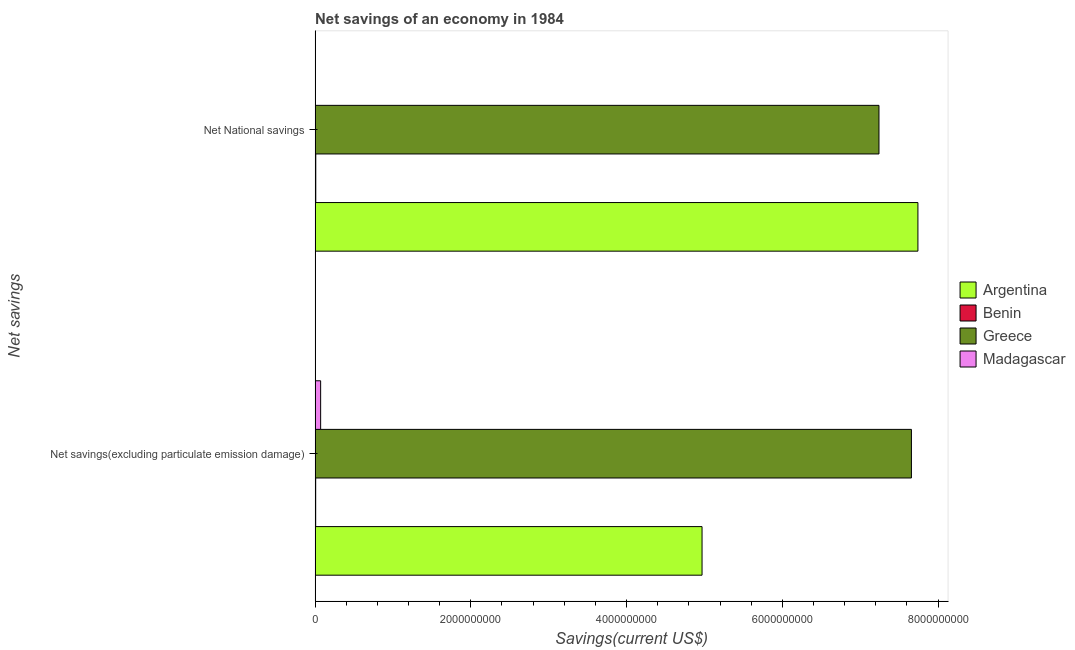How many groups of bars are there?
Make the answer very short. 2. Are the number of bars on each tick of the Y-axis equal?
Keep it short and to the point. No. What is the label of the 2nd group of bars from the top?
Your answer should be compact. Net savings(excluding particulate emission damage). What is the net national savings in Benin?
Keep it short and to the point. 8.73e+06. Across all countries, what is the maximum net savings(excluding particulate emission damage)?
Keep it short and to the point. 7.66e+09. In which country was the net national savings maximum?
Offer a very short reply. Argentina. What is the total net savings(excluding particulate emission damage) in the graph?
Give a very brief answer. 1.27e+1. What is the difference between the net savings(excluding particulate emission damage) in Madagascar and that in Greece?
Your answer should be very brief. -7.59e+09. What is the difference between the net national savings in Madagascar and the net savings(excluding particulate emission damage) in Argentina?
Your response must be concise. -4.97e+09. What is the average net national savings per country?
Provide a succinct answer. 3.75e+09. What is the difference between the net savings(excluding particulate emission damage) and net national savings in Argentina?
Your answer should be very brief. -2.77e+09. What is the ratio of the net savings(excluding particulate emission damage) in Greece to that in Benin?
Provide a succinct answer. 1007.17. In how many countries, is the net savings(excluding particulate emission damage) greater than the average net savings(excluding particulate emission damage) taken over all countries?
Offer a terse response. 2. What is the difference between two consecutive major ticks on the X-axis?
Provide a short and direct response. 2.00e+09. Does the graph contain any zero values?
Your answer should be very brief. Yes. How many legend labels are there?
Make the answer very short. 4. How are the legend labels stacked?
Give a very brief answer. Vertical. What is the title of the graph?
Ensure brevity in your answer.  Net savings of an economy in 1984. What is the label or title of the X-axis?
Keep it short and to the point. Savings(current US$). What is the label or title of the Y-axis?
Your answer should be very brief. Net savings. What is the Savings(current US$) in Argentina in Net savings(excluding particulate emission damage)?
Provide a succinct answer. 4.97e+09. What is the Savings(current US$) in Benin in Net savings(excluding particulate emission damage)?
Ensure brevity in your answer.  7.60e+06. What is the Savings(current US$) in Greece in Net savings(excluding particulate emission damage)?
Provide a short and direct response. 7.66e+09. What is the Savings(current US$) of Madagascar in Net savings(excluding particulate emission damage)?
Make the answer very short. 7.12e+07. What is the Savings(current US$) of Argentina in Net National savings?
Ensure brevity in your answer.  7.74e+09. What is the Savings(current US$) in Benin in Net National savings?
Make the answer very short. 8.73e+06. What is the Savings(current US$) of Greece in Net National savings?
Make the answer very short. 7.24e+09. Across all Net savings, what is the maximum Savings(current US$) of Argentina?
Your answer should be very brief. 7.74e+09. Across all Net savings, what is the maximum Savings(current US$) in Benin?
Ensure brevity in your answer.  8.73e+06. Across all Net savings, what is the maximum Savings(current US$) in Greece?
Give a very brief answer. 7.66e+09. Across all Net savings, what is the maximum Savings(current US$) in Madagascar?
Give a very brief answer. 7.12e+07. Across all Net savings, what is the minimum Savings(current US$) of Argentina?
Provide a succinct answer. 4.97e+09. Across all Net savings, what is the minimum Savings(current US$) in Benin?
Provide a succinct answer. 7.60e+06. Across all Net savings, what is the minimum Savings(current US$) of Greece?
Offer a terse response. 7.24e+09. Across all Net savings, what is the minimum Savings(current US$) in Madagascar?
Provide a short and direct response. 0. What is the total Savings(current US$) in Argentina in the graph?
Give a very brief answer. 1.27e+1. What is the total Savings(current US$) of Benin in the graph?
Provide a succinct answer. 1.63e+07. What is the total Savings(current US$) in Greece in the graph?
Keep it short and to the point. 1.49e+1. What is the total Savings(current US$) of Madagascar in the graph?
Provide a short and direct response. 7.12e+07. What is the difference between the Savings(current US$) in Argentina in Net savings(excluding particulate emission damage) and that in Net National savings?
Provide a succinct answer. -2.77e+09. What is the difference between the Savings(current US$) of Benin in Net savings(excluding particulate emission damage) and that in Net National savings?
Make the answer very short. -1.13e+06. What is the difference between the Savings(current US$) in Greece in Net savings(excluding particulate emission damage) and that in Net National savings?
Your answer should be compact. 4.17e+08. What is the difference between the Savings(current US$) of Argentina in Net savings(excluding particulate emission damage) and the Savings(current US$) of Benin in Net National savings?
Offer a terse response. 4.96e+09. What is the difference between the Savings(current US$) of Argentina in Net savings(excluding particulate emission damage) and the Savings(current US$) of Greece in Net National savings?
Provide a short and direct response. -2.27e+09. What is the difference between the Savings(current US$) in Benin in Net savings(excluding particulate emission damage) and the Savings(current US$) in Greece in Net National savings?
Your response must be concise. -7.23e+09. What is the average Savings(current US$) of Argentina per Net savings?
Offer a very short reply. 6.36e+09. What is the average Savings(current US$) in Benin per Net savings?
Provide a short and direct response. 8.17e+06. What is the average Savings(current US$) in Greece per Net savings?
Your answer should be very brief. 7.45e+09. What is the average Savings(current US$) in Madagascar per Net savings?
Provide a succinct answer. 3.56e+07. What is the difference between the Savings(current US$) of Argentina and Savings(current US$) of Benin in Net savings(excluding particulate emission damage)?
Keep it short and to the point. 4.96e+09. What is the difference between the Savings(current US$) in Argentina and Savings(current US$) in Greece in Net savings(excluding particulate emission damage)?
Offer a very short reply. -2.69e+09. What is the difference between the Savings(current US$) of Argentina and Savings(current US$) of Madagascar in Net savings(excluding particulate emission damage)?
Offer a terse response. 4.90e+09. What is the difference between the Savings(current US$) of Benin and Savings(current US$) of Greece in Net savings(excluding particulate emission damage)?
Offer a very short reply. -7.65e+09. What is the difference between the Savings(current US$) in Benin and Savings(current US$) in Madagascar in Net savings(excluding particulate emission damage)?
Make the answer very short. -6.36e+07. What is the difference between the Savings(current US$) in Greece and Savings(current US$) in Madagascar in Net savings(excluding particulate emission damage)?
Keep it short and to the point. 7.59e+09. What is the difference between the Savings(current US$) of Argentina and Savings(current US$) of Benin in Net National savings?
Offer a very short reply. 7.73e+09. What is the difference between the Savings(current US$) in Argentina and Savings(current US$) in Greece in Net National savings?
Make the answer very short. 5.00e+08. What is the difference between the Savings(current US$) of Benin and Savings(current US$) of Greece in Net National savings?
Offer a terse response. -7.23e+09. What is the ratio of the Savings(current US$) in Argentina in Net savings(excluding particulate emission damage) to that in Net National savings?
Keep it short and to the point. 0.64. What is the ratio of the Savings(current US$) in Benin in Net savings(excluding particulate emission damage) to that in Net National savings?
Provide a succinct answer. 0.87. What is the ratio of the Savings(current US$) of Greece in Net savings(excluding particulate emission damage) to that in Net National savings?
Your answer should be very brief. 1.06. What is the difference between the highest and the second highest Savings(current US$) of Argentina?
Your answer should be very brief. 2.77e+09. What is the difference between the highest and the second highest Savings(current US$) of Benin?
Provide a succinct answer. 1.13e+06. What is the difference between the highest and the second highest Savings(current US$) of Greece?
Keep it short and to the point. 4.17e+08. What is the difference between the highest and the lowest Savings(current US$) in Argentina?
Provide a succinct answer. 2.77e+09. What is the difference between the highest and the lowest Savings(current US$) in Benin?
Provide a short and direct response. 1.13e+06. What is the difference between the highest and the lowest Savings(current US$) of Greece?
Offer a very short reply. 4.17e+08. What is the difference between the highest and the lowest Savings(current US$) of Madagascar?
Your answer should be compact. 7.12e+07. 